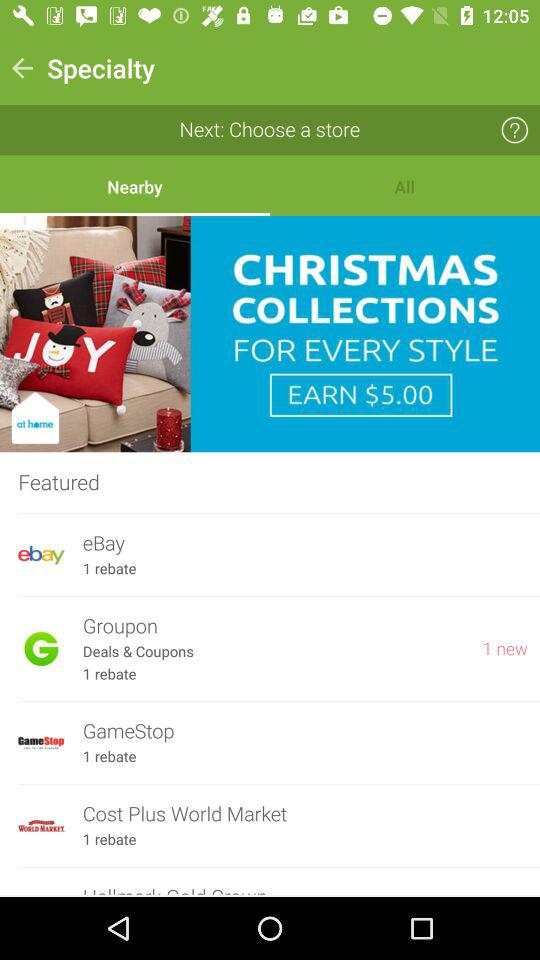What is the total number of rebates in the groupon? The total number of rebates is 1. 